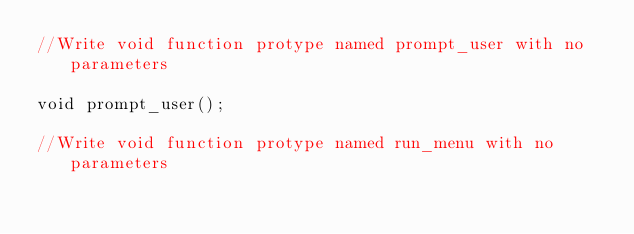Convert code to text. <code><loc_0><loc_0><loc_500><loc_500><_C_>//Write void function protype named prompt_user with no parameters

void prompt_user();

//Write void function protype named run_menu with no parameters

</code> 